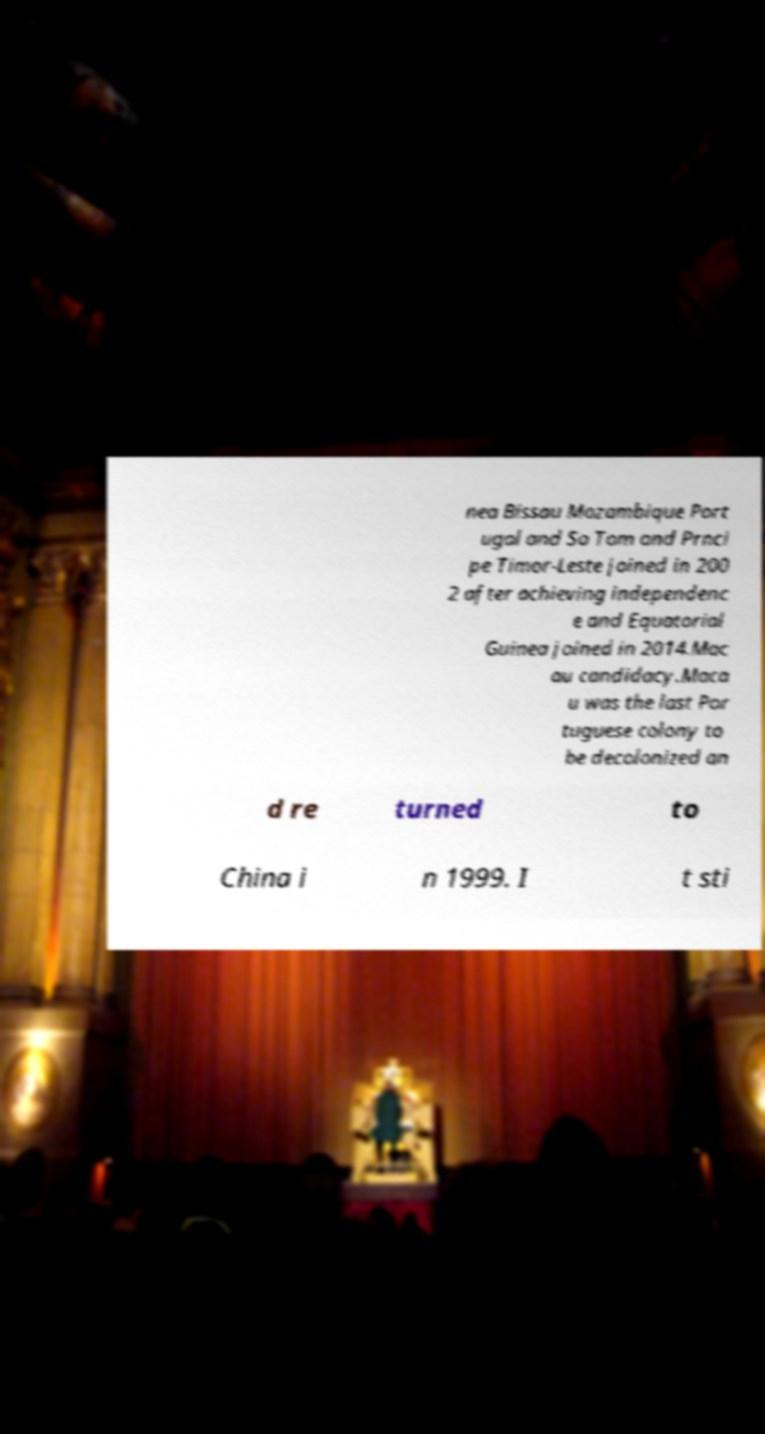Can you read and provide the text displayed in the image?This photo seems to have some interesting text. Can you extract and type it out for me? nea Bissau Mozambique Port ugal and So Tom and Prnci pe Timor-Leste joined in 200 2 after achieving independenc e and Equatorial Guinea joined in 2014.Mac au candidacy.Maca u was the last Por tuguese colony to be decolonized an d re turned to China i n 1999. I t sti 